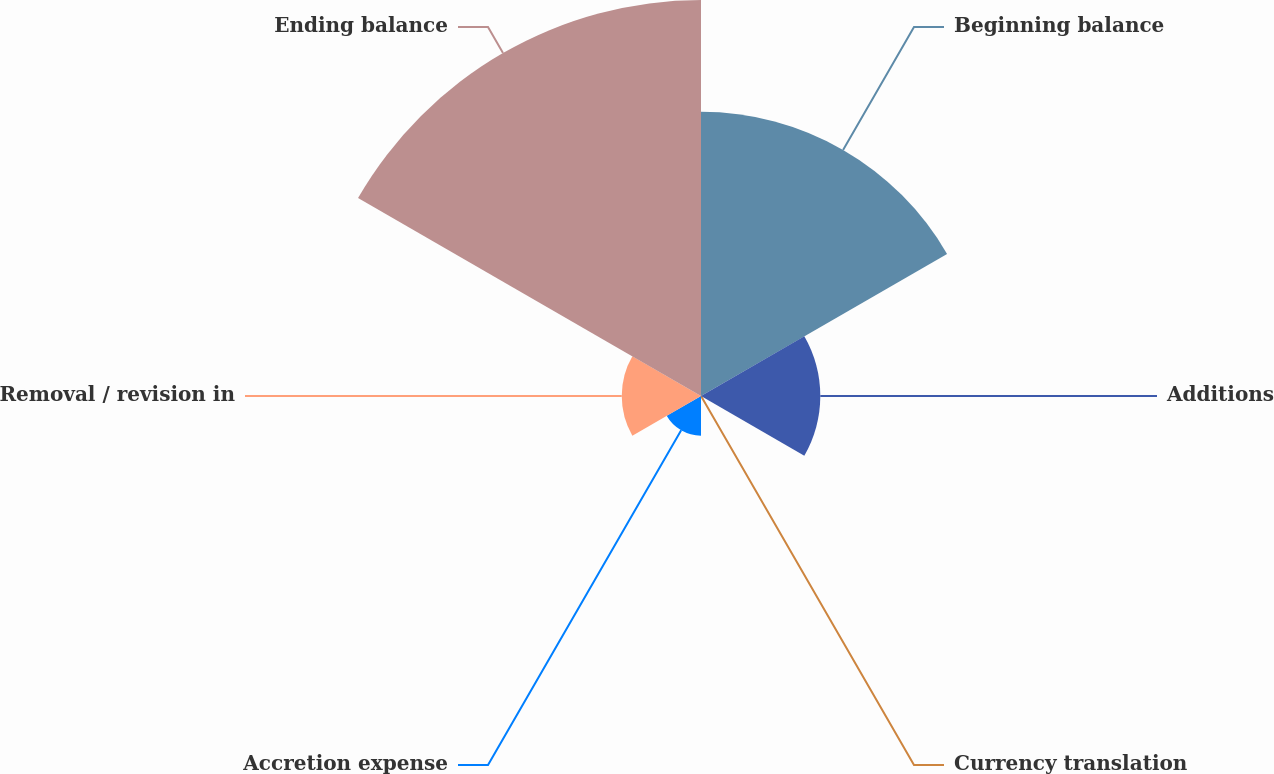Convert chart. <chart><loc_0><loc_0><loc_500><loc_500><pie_chart><fcel>Beginning balance<fcel>Additions<fcel>Currency translation<fcel>Accretion expense<fcel>Removal / revision in<fcel>Ending balance<nl><fcel>30.94%<fcel>12.99%<fcel>0.01%<fcel>4.32%<fcel>8.63%<fcel>43.12%<nl></chart> 